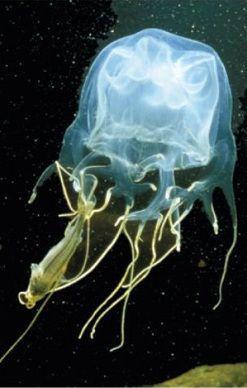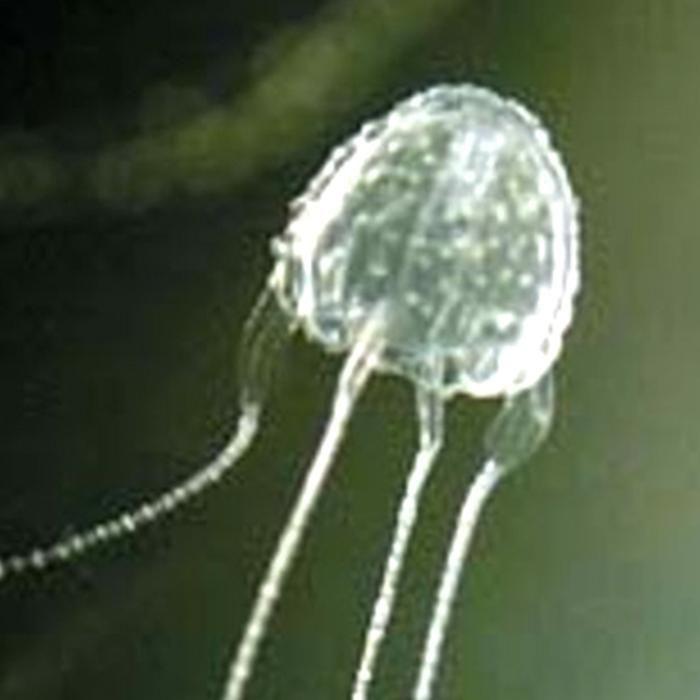The first image is the image on the left, the second image is the image on the right. For the images displayed, is the sentence "The jellyfish on the right is blue and has four tentacles." factually correct? Answer yes or no. No. 